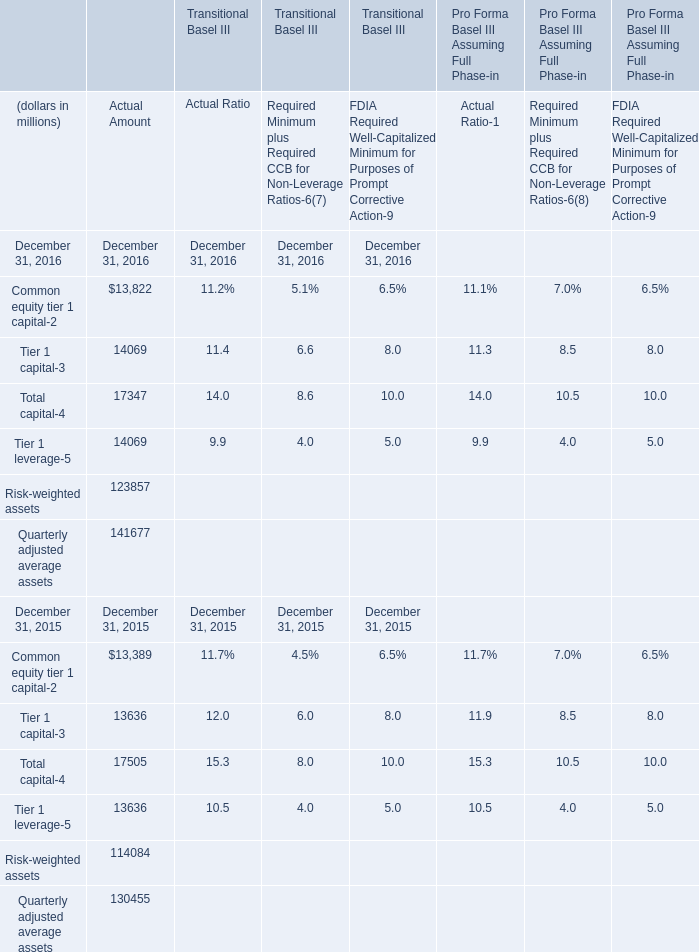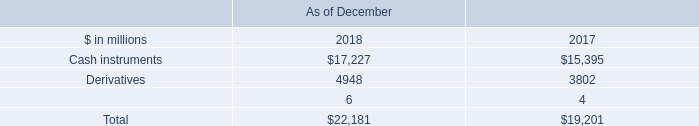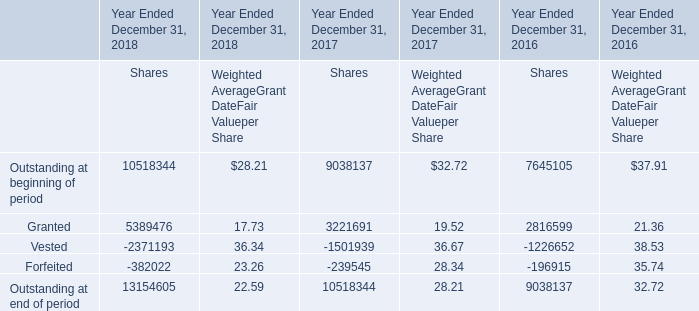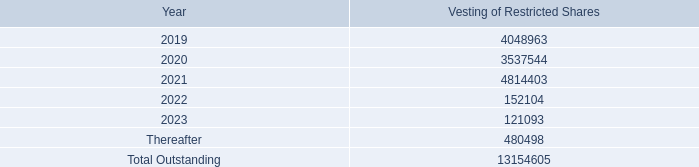What's the average of 2023 of Vesting of Restricted Shares 4,048,963 3,537,544 4,814,403, and Derivatives of As of December 2018 ? 
Computations: ((121093.0 + 4948.0) / 2)
Answer: 63020.5. what's the total amount of Derivatives of As of December 2018, and Granted of Year Ended December 31, 2017 Shares ? 
Computations: (4948.0 + 3221691.0)
Answer: 3226639.0. 